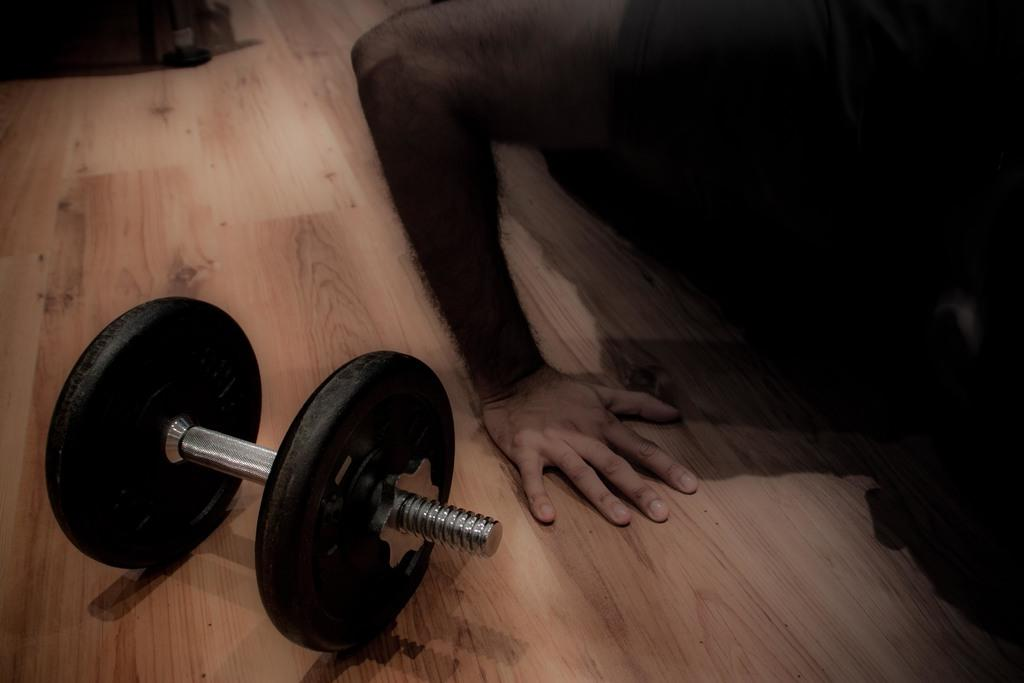What type of equipment can be seen in the image? There is gym equipment in the image. Can you describe the person in the image? There is a person in the image. What color is the floor in the image? The floor is brown in color. Is the doll stuck in quicksand in the image? There is no doll or quicksand present in the image. Can you see a rabbit hopping in the background of the image? There is no rabbit present in the image. 